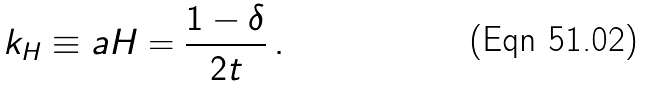<formula> <loc_0><loc_0><loc_500><loc_500>k _ { H } \equiv a H = \frac { 1 - \delta } { 2 t } \, .</formula> 